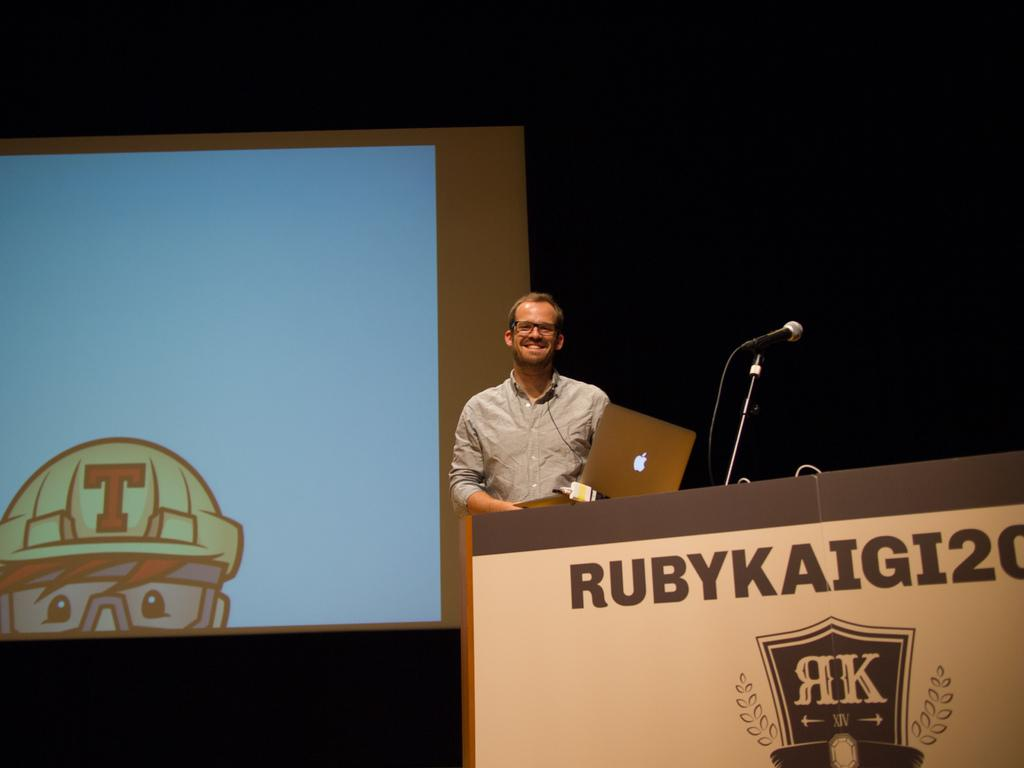What is the person in the image doing? The person is standing near a podium in the image. What electronic device is visible in the image? There is a laptop in the image. What can be seen in the background of the image? There is a screen in the background of the image. What type of fuel is being used to power the laptop in the image? The laptop in the image is not powered by fuel; it is likely powered by electricity or battery. 